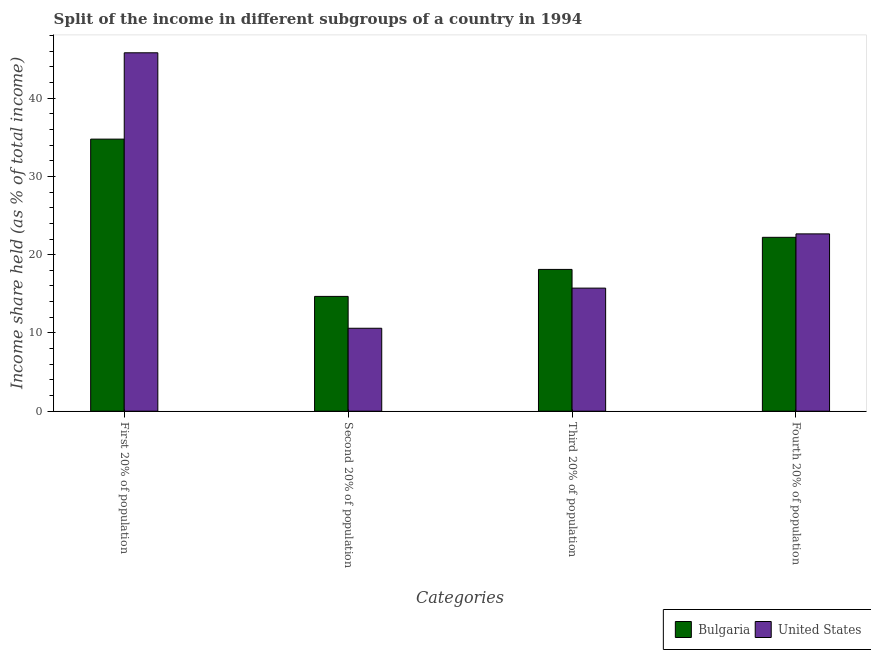How many different coloured bars are there?
Ensure brevity in your answer.  2. Are the number of bars on each tick of the X-axis equal?
Ensure brevity in your answer.  Yes. What is the label of the 3rd group of bars from the left?
Make the answer very short. Third 20% of population. What is the share of the income held by third 20% of the population in Bulgaria?
Provide a succinct answer. 18.12. Across all countries, what is the maximum share of the income held by third 20% of the population?
Give a very brief answer. 18.12. Across all countries, what is the minimum share of the income held by third 20% of the population?
Provide a short and direct response. 15.73. What is the total share of the income held by second 20% of the population in the graph?
Provide a short and direct response. 25.27. What is the difference between the share of the income held by first 20% of the population in Bulgaria and that in United States?
Provide a short and direct response. -11.03. What is the difference between the share of the income held by third 20% of the population in United States and the share of the income held by fourth 20% of the population in Bulgaria?
Offer a very short reply. -6.49. What is the average share of the income held by second 20% of the population per country?
Give a very brief answer. 12.63. What is the difference between the share of the income held by second 20% of the population and share of the income held by fourth 20% of the population in Bulgaria?
Your answer should be very brief. -7.55. In how many countries, is the share of the income held by first 20% of the population greater than 22 %?
Give a very brief answer. 2. What is the ratio of the share of the income held by first 20% of the population in Bulgaria to that in United States?
Your answer should be very brief. 0.76. What is the difference between the highest and the second highest share of the income held by first 20% of the population?
Provide a short and direct response. 11.03. What is the difference between the highest and the lowest share of the income held by first 20% of the population?
Your answer should be very brief. 11.03. Is the sum of the share of the income held by second 20% of the population in Bulgaria and United States greater than the maximum share of the income held by third 20% of the population across all countries?
Ensure brevity in your answer.  Yes. Is it the case that in every country, the sum of the share of the income held by second 20% of the population and share of the income held by first 20% of the population is greater than the sum of share of the income held by fourth 20% of the population and share of the income held by third 20% of the population?
Keep it short and to the point. Yes. Is it the case that in every country, the sum of the share of the income held by first 20% of the population and share of the income held by second 20% of the population is greater than the share of the income held by third 20% of the population?
Keep it short and to the point. Yes. Are all the bars in the graph horizontal?
Keep it short and to the point. No. How many countries are there in the graph?
Keep it short and to the point. 2. What is the difference between two consecutive major ticks on the Y-axis?
Provide a short and direct response. 10. Does the graph contain any zero values?
Make the answer very short. No. How many legend labels are there?
Your answer should be compact. 2. What is the title of the graph?
Provide a short and direct response. Split of the income in different subgroups of a country in 1994. What is the label or title of the X-axis?
Make the answer very short. Categories. What is the label or title of the Y-axis?
Make the answer very short. Income share held (as % of total income). What is the Income share held (as % of total income) of Bulgaria in First 20% of population?
Provide a succinct answer. 34.77. What is the Income share held (as % of total income) in United States in First 20% of population?
Provide a short and direct response. 45.8. What is the Income share held (as % of total income) in Bulgaria in Second 20% of population?
Provide a short and direct response. 14.67. What is the Income share held (as % of total income) in Bulgaria in Third 20% of population?
Keep it short and to the point. 18.12. What is the Income share held (as % of total income) in United States in Third 20% of population?
Ensure brevity in your answer.  15.73. What is the Income share held (as % of total income) of Bulgaria in Fourth 20% of population?
Make the answer very short. 22.22. What is the Income share held (as % of total income) in United States in Fourth 20% of population?
Keep it short and to the point. 22.66. Across all Categories, what is the maximum Income share held (as % of total income) in Bulgaria?
Provide a succinct answer. 34.77. Across all Categories, what is the maximum Income share held (as % of total income) of United States?
Keep it short and to the point. 45.8. Across all Categories, what is the minimum Income share held (as % of total income) of Bulgaria?
Ensure brevity in your answer.  14.67. What is the total Income share held (as % of total income) in Bulgaria in the graph?
Your answer should be compact. 89.78. What is the total Income share held (as % of total income) of United States in the graph?
Provide a succinct answer. 94.79. What is the difference between the Income share held (as % of total income) in Bulgaria in First 20% of population and that in Second 20% of population?
Your answer should be very brief. 20.1. What is the difference between the Income share held (as % of total income) in United States in First 20% of population and that in Second 20% of population?
Keep it short and to the point. 35.2. What is the difference between the Income share held (as % of total income) in Bulgaria in First 20% of population and that in Third 20% of population?
Keep it short and to the point. 16.65. What is the difference between the Income share held (as % of total income) of United States in First 20% of population and that in Third 20% of population?
Offer a very short reply. 30.07. What is the difference between the Income share held (as % of total income) of Bulgaria in First 20% of population and that in Fourth 20% of population?
Your answer should be very brief. 12.55. What is the difference between the Income share held (as % of total income) in United States in First 20% of population and that in Fourth 20% of population?
Your response must be concise. 23.14. What is the difference between the Income share held (as % of total income) in Bulgaria in Second 20% of population and that in Third 20% of population?
Give a very brief answer. -3.45. What is the difference between the Income share held (as % of total income) in United States in Second 20% of population and that in Third 20% of population?
Provide a succinct answer. -5.13. What is the difference between the Income share held (as % of total income) of Bulgaria in Second 20% of population and that in Fourth 20% of population?
Offer a terse response. -7.55. What is the difference between the Income share held (as % of total income) of United States in Second 20% of population and that in Fourth 20% of population?
Offer a terse response. -12.06. What is the difference between the Income share held (as % of total income) in Bulgaria in Third 20% of population and that in Fourth 20% of population?
Keep it short and to the point. -4.1. What is the difference between the Income share held (as % of total income) in United States in Third 20% of population and that in Fourth 20% of population?
Give a very brief answer. -6.93. What is the difference between the Income share held (as % of total income) of Bulgaria in First 20% of population and the Income share held (as % of total income) of United States in Second 20% of population?
Provide a succinct answer. 24.17. What is the difference between the Income share held (as % of total income) in Bulgaria in First 20% of population and the Income share held (as % of total income) in United States in Third 20% of population?
Ensure brevity in your answer.  19.04. What is the difference between the Income share held (as % of total income) in Bulgaria in First 20% of population and the Income share held (as % of total income) in United States in Fourth 20% of population?
Offer a very short reply. 12.11. What is the difference between the Income share held (as % of total income) in Bulgaria in Second 20% of population and the Income share held (as % of total income) in United States in Third 20% of population?
Give a very brief answer. -1.06. What is the difference between the Income share held (as % of total income) in Bulgaria in Second 20% of population and the Income share held (as % of total income) in United States in Fourth 20% of population?
Keep it short and to the point. -7.99. What is the difference between the Income share held (as % of total income) in Bulgaria in Third 20% of population and the Income share held (as % of total income) in United States in Fourth 20% of population?
Give a very brief answer. -4.54. What is the average Income share held (as % of total income) of Bulgaria per Categories?
Ensure brevity in your answer.  22.45. What is the average Income share held (as % of total income) of United States per Categories?
Make the answer very short. 23.7. What is the difference between the Income share held (as % of total income) of Bulgaria and Income share held (as % of total income) of United States in First 20% of population?
Offer a very short reply. -11.03. What is the difference between the Income share held (as % of total income) in Bulgaria and Income share held (as % of total income) in United States in Second 20% of population?
Provide a succinct answer. 4.07. What is the difference between the Income share held (as % of total income) of Bulgaria and Income share held (as % of total income) of United States in Third 20% of population?
Give a very brief answer. 2.39. What is the difference between the Income share held (as % of total income) in Bulgaria and Income share held (as % of total income) in United States in Fourth 20% of population?
Provide a succinct answer. -0.44. What is the ratio of the Income share held (as % of total income) of Bulgaria in First 20% of population to that in Second 20% of population?
Ensure brevity in your answer.  2.37. What is the ratio of the Income share held (as % of total income) of United States in First 20% of population to that in Second 20% of population?
Give a very brief answer. 4.32. What is the ratio of the Income share held (as % of total income) of Bulgaria in First 20% of population to that in Third 20% of population?
Ensure brevity in your answer.  1.92. What is the ratio of the Income share held (as % of total income) of United States in First 20% of population to that in Third 20% of population?
Give a very brief answer. 2.91. What is the ratio of the Income share held (as % of total income) in Bulgaria in First 20% of population to that in Fourth 20% of population?
Your answer should be very brief. 1.56. What is the ratio of the Income share held (as % of total income) of United States in First 20% of population to that in Fourth 20% of population?
Give a very brief answer. 2.02. What is the ratio of the Income share held (as % of total income) of Bulgaria in Second 20% of population to that in Third 20% of population?
Keep it short and to the point. 0.81. What is the ratio of the Income share held (as % of total income) in United States in Second 20% of population to that in Third 20% of population?
Make the answer very short. 0.67. What is the ratio of the Income share held (as % of total income) in Bulgaria in Second 20% of population to that in Fourth 20% of population?
Your response must be concise. 0.66. What is the ratio of the Income share held (as % of total income) of United States in Second 20% of population to that in Fourth 20% of population?
Keep it short and to the point. 0.47. What is the ratio of the Income share held (as % of total income) of Bulgaria in Third 20% of population to that in Fourth 20% of population?
Offer a very short reply. 0.82. What is the ratio of the Income share held (as % of total income) in United States in Third 20% of population to that in Fourth 20% of population?
Provide a succinct answer. 0.69. What is the difference between the highest and the second highest Income share held (as % of total income) in Bulgaria?
Provide a short and direct response. 12.55. What is the difference between the highest and the second highest Income share held (as % of total income) of United States?
Keep it short and to the point. 23.14. What is the difference between the highest and the lowest Income share held (as % of total income) in Bulgaria?
Your answer should be compact. 20.1. What is the difference between the highest and the lowest Income share held (as % of total income) of United States?
Your answer should be compact. 35.2. 